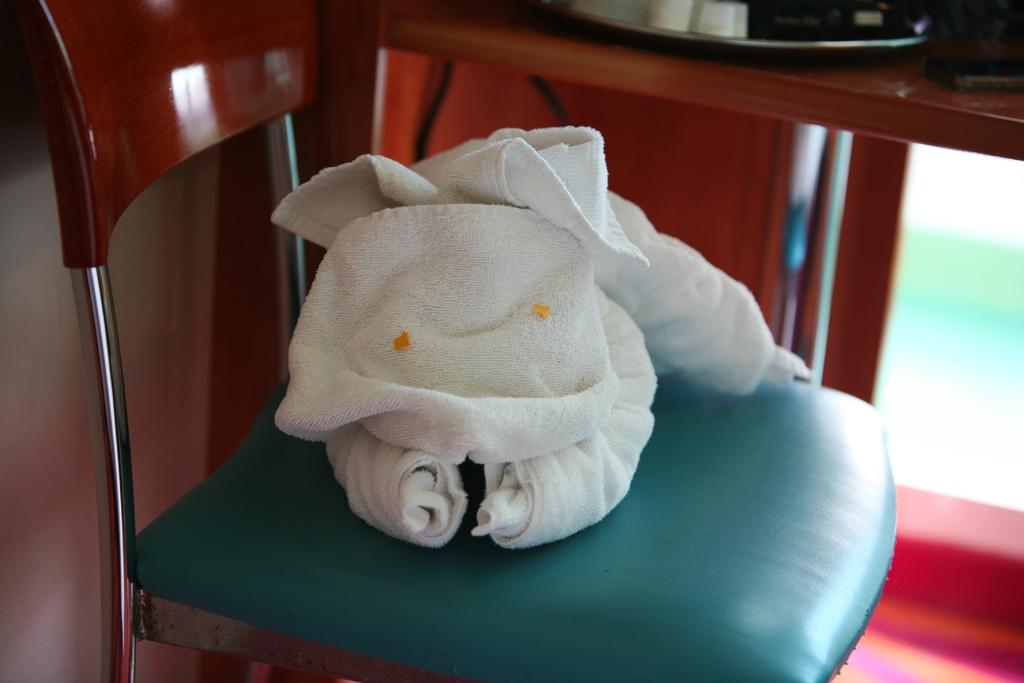What is placed on the chair in the image? There is a towel on a chair in the image. What can be seen on the table in the image? There are objects on a table in the image. Can you describe the background of the image? The background of the image is blurry. What type of bead is used to decorate the hall in the image? There is no mention of a hall or beads in the image; it only features a towel on a chair and objects on a table. 